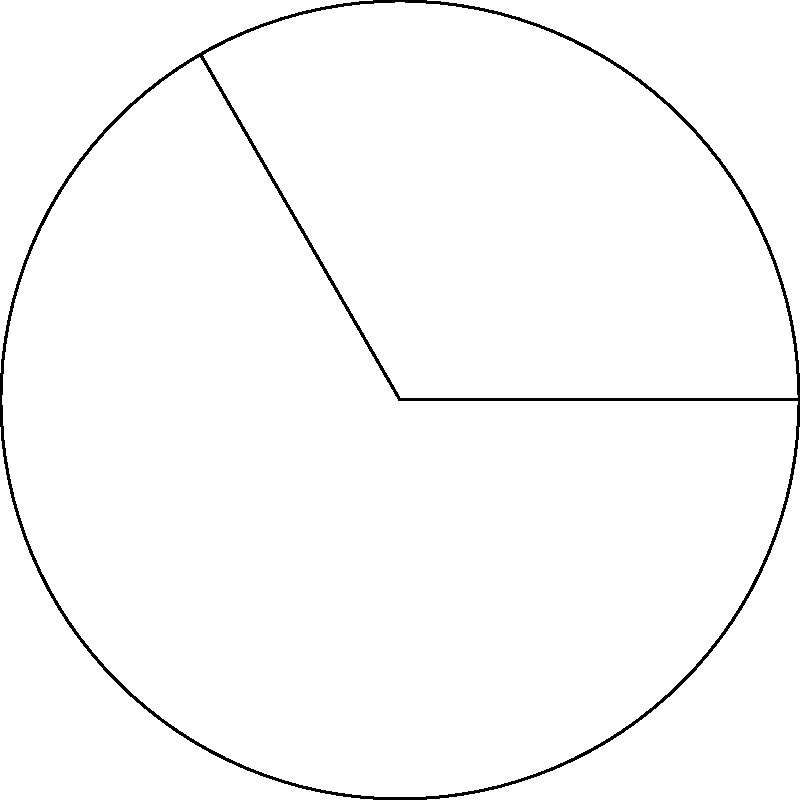As the university president, you're analyzing the allocation of research funding across different departments. The circular chart represents the total research budget, and you need to calculate the funding for a specific group of departments. If the total research budget is $18 million and the sector angle for these departments is $120°$, what is the amount of funding allocated to this group? Let's approach this step-by-step:

1) The area of a circular sector is proportional to its central angle. The formula for the area of a sector is:

   $$A_{sector} = \frac{\theta}{360°} \cdot \pi r^2$$

   Where $\theta$ is the central angle in degrees and $r$ is the radius.

2) In this case, we don't need to know the actual radius of the circle. We just need to know that the total area (360°) represents $18 million.

3) The sector we're interested in has an angle of 120°. So we can set up the proportion:

   $$\frac{120°}{360°} = \frac{x}{18,000,000}$$

   Where $x$ is the amount we're looking for.

4) Simplify the left side of the equation:

   $$\frac{1}{3} = \frac{x}{18,000,000}$$

5) Cross multiply:

   $$1 \cdot 18,000,000 = 3x$$

6) Solve for $x$:

   $$x = \frac{18,000,000}{3} = 6,000,000$$

Therefore, the amount allocated to this group of departments is $6 million.
Answer: $6 million 